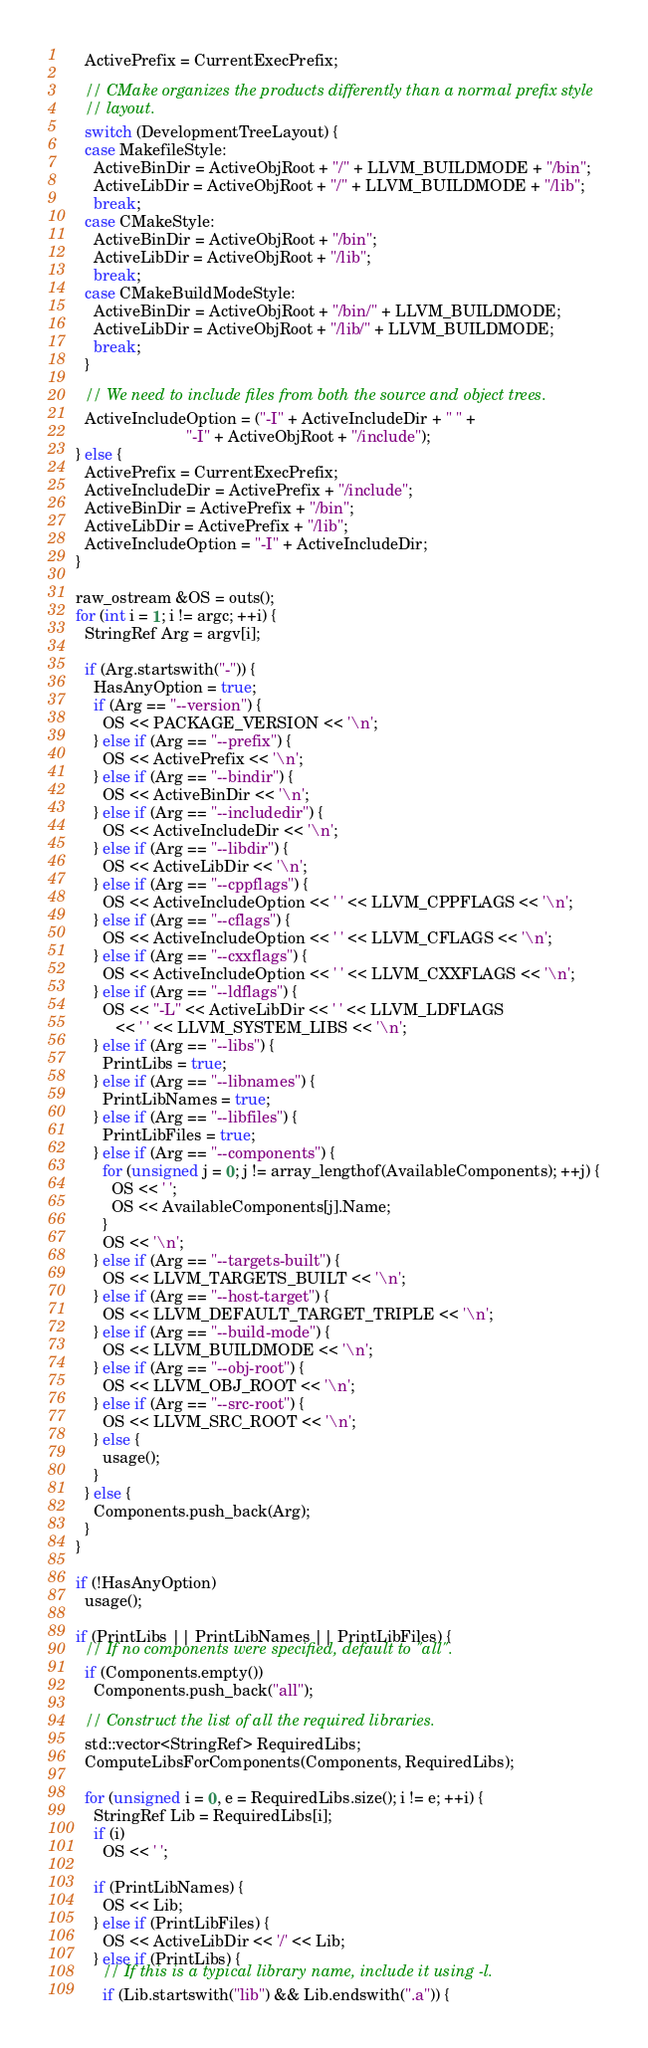Convert code to text. <code><loc_0><loc_0><loc_500><loc_500><_C++_>    ActivePrefix = CurrentExecPrefix;

    // CMake organizes the products differently than a normal prefix style
    // layout.
    switch (DevelopmentTreeLayout) {
    case MakefileStyle:
      ActiveBinDir = ActiveObjRoot + "/" + LLVM_BUILDMODE + "/bin";
      ActiveLibDir = ActiveObjRoot + "/" + LLVM_BUILDMODE + "/lib";
      break;
    case CMakeStyle:
      ActiveBinDir = ActiveObjRoot + "/bin";
      ActiveLibDir = ActiveObjRoot + "/lib";
      break;
    case CMakeBuildModeStyle:
      ActiveBinDir = ActiveObjRoot + "/bin/" + LLVM_BUILDMODE;
      ActiveLibDir = ActiveObjRoot + "/lib/" + LLVM_BUILDMODE;
      break;
    }

    // We need to include files from both the source and object trees.
    ActiveIncludeOption = ("-I" + ActiveIncludeDir + " " +
                           "-I" + ActiveObjRoot + "/include");
  } else {
    ActivePrefix = CurrentExecPrefix;
    ActiveIncludeDir = ActivePrefix + "/include";
    ActiveBinDir = ActivePrefix + "/bin";
    ActiveLibDir = ActivePrefix + "/lib";
    ActiveIncludeOption = "-I" + ActiveIncludeDir;
  }

  raw_ostream &OS = outs();
  for (int i = 1; i != argc; ++i) {
    StringRef Arg = argv[i];

    if (Arg.startswith("-")) {
      HasAnyOption = true;
      if (Arg == "--version") {
        OS << PACKAGE_VERSION << '\n';
      } else if (Arg == "--prefix") {
        OS << ActivePrefix << '\n';
      } else if (Arg == "--bindir") {
        OS << ActiveBinDir << '\n';
      } else if (Arg == "--includedir") {
        OS << ActiveIncludeDir << '\n';
      } else if (Arg == "--libdir") {
        OS << ActiveLibDir << '\n';
      } else if (Arg == "--cppflags") {
        OS << ActiveIncludeOption << ' ' << LLVM_CPPFLAGS << '\n';
      } else if (Arg == "--cflags") {
        OS << ActiveIncludeOption << ' ' << LLVM_CFLAGS << '\n';
      } else if (Arg == "--cxxflags") {
        OS << ActiveIncludeOption << ' ' << LLVM_CXXFLAGS << '\n';
      } else if (Arg == "--ldflags") {
        OS << "-L" << ActiveLibDir << ' ' << LLVM_LDFLAGS
           << ' ' << LLVM_SYSTEM_LIBS << '\n';
      } else if (Arg == "--libs") {
        PrintLibs = true;
      } else if (Arg == "--libnames") {
        PrintLibNames = true;
      } else if (Arg == "--libfiles") {
        PrintLibFiles = true;
      } else if (Arg == "--components") {
        for (unsigned j = 0; j != array_lengthof(AvailableComponents); ++j) {
          OS << ' ';
          OS << AvailableComponents[j].Name;
        }
        OS << '\n';
      } else if (Arg == "--targets-built") {
        OS << LLVM_TARGETS_BUILT << '\n';
      } else if (Arg == "--host-target") {
        OS << LLVM_DEFAULT_TARGET_TRIPLE << '\n';
      } else if (Arg == "--build-mode") {
        OS << LLVM_BUILDMODE << '\n';
      } else if (Arg == "--obj-root") {
        OS << LLVM_OBJ_ROOT << '\n';
      } else if (Arg == "--src-root") {
        OS << LLVM_SRC_ROOT << '\n';
      } else {
        usage();
      }
    } else {
      Components.push_back(Arg);
    }
  }

  if (!HasAnyOption)
    usage();

  if (PrintLibs || PrintLibNames || PrintLibFiles) {
    // If no components were specified, default to "all".
    if (Components.empty())
      Components.push_back("all");

    // Construct the list of all the required libraries.
    std::vector<StringRef> RequiredLibs;
    ComputeLibsForComponents(Components, RequiredLibs);

    for (unsigned i = 0, e = RequiredLibs.size(); i != e; ++i) {
      StringRef Lib = RequiredLibs[i];
      if (i)
        OS << ' ';

      if (PrintLibNames) {
        OS << Lib;
      } else if (PrintLibFiles) {
        OS << ActiveLibDir << '/' << Lib;
      } else if (PrintLibs) {
        // If this is a typical library name, include it using -l.
        if (Lib.startswith("lib") && Lib.endswith(".a")) {</code> 